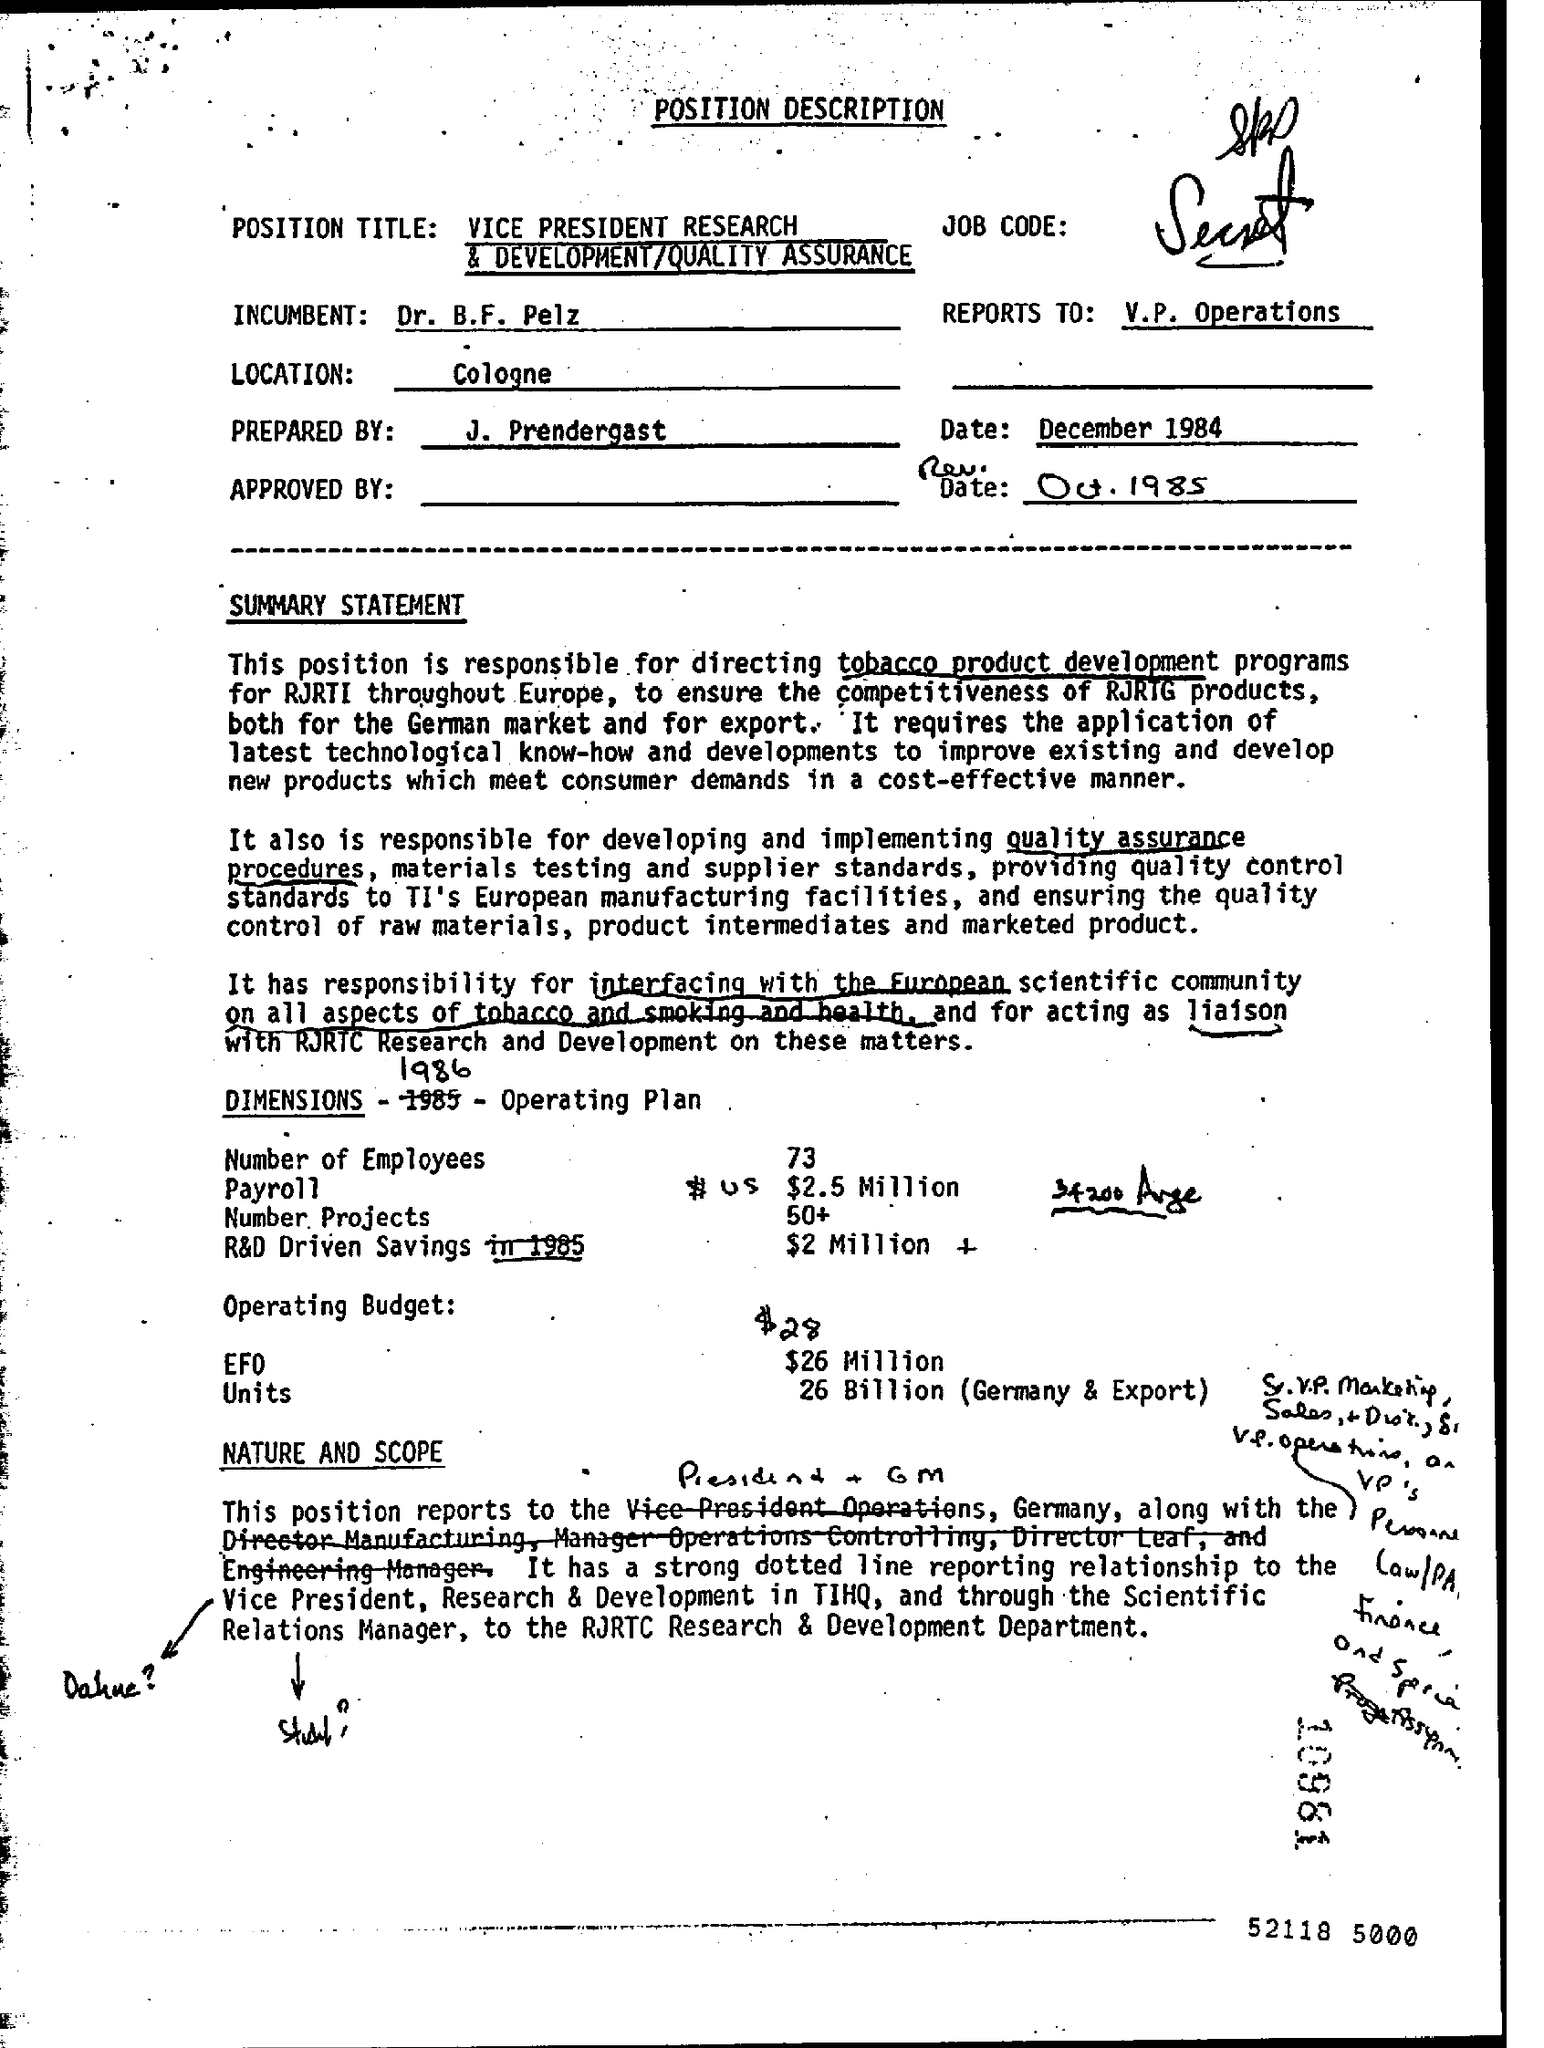Identify some key points in this picture. The preparedness of this document is attributed to J. Prendergast. The letterhead contains the position description. The location is in Cologne. The date mentioned at the top of the document is December 1984. 